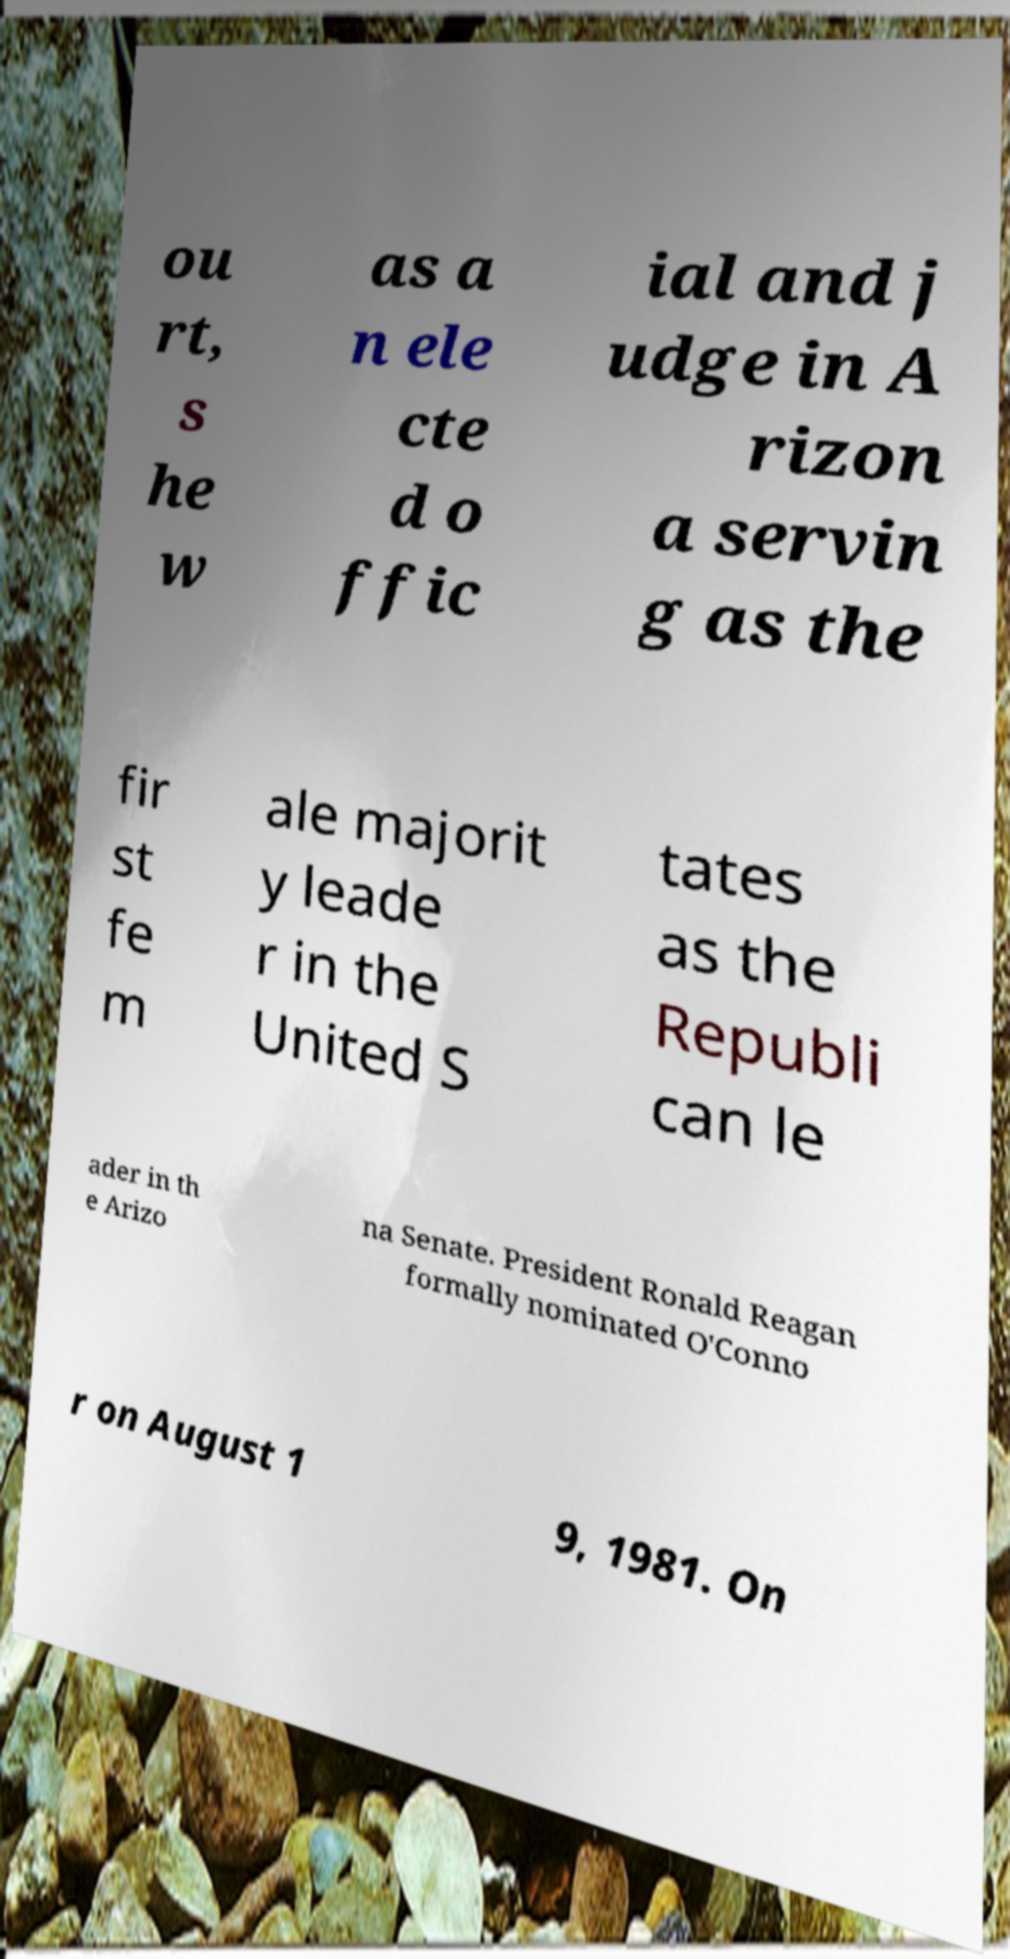What messages or text are displayed in this image? I need them in a readable, typed format. ou rt, s he w as a n ele cte d o ffic ial and j udge in A rizon a servin g as the fir st fe m ale majorit y leade r in the United S tates as the Republi can le ader in th e Arizo na Senate. President Ronald Reagan formally nominated O'Conno r on August 1 9, 1981. On 